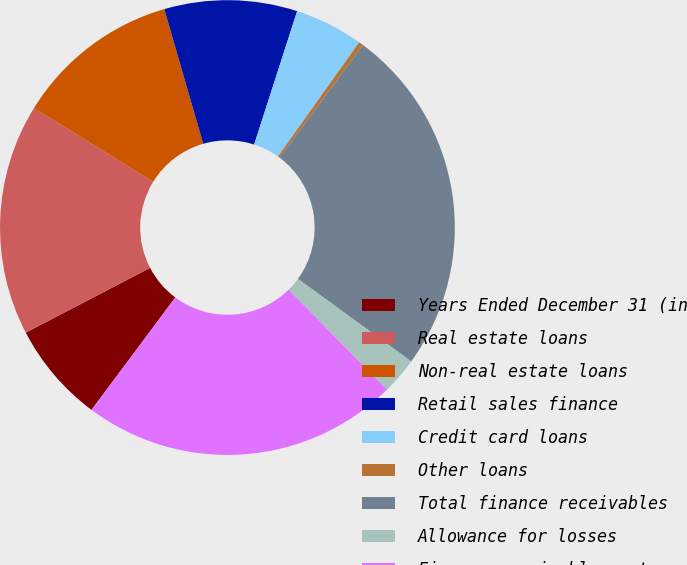<chart> <loc_0><loc_0><loc_500><loc_500><pie_chart><fcel>Years Ended December 31 (in<fcel>Real estate loans<fcel>Non-real estate loans<fcel>Retail sales finance<fcel>Credit card loans<fcel>Other loans<fcel>Total finance receivables<fcel>Allowance for losses<fcel>Finance receivables net<nl><fcel>7.16%<fcel>16.45%<fcel>11.72%<fcel>9.44%<fcel>4.88%<fcel>0.33%<fcel>24.85%<fcel>2.61%<fcel>22.57%<nl></chart> 